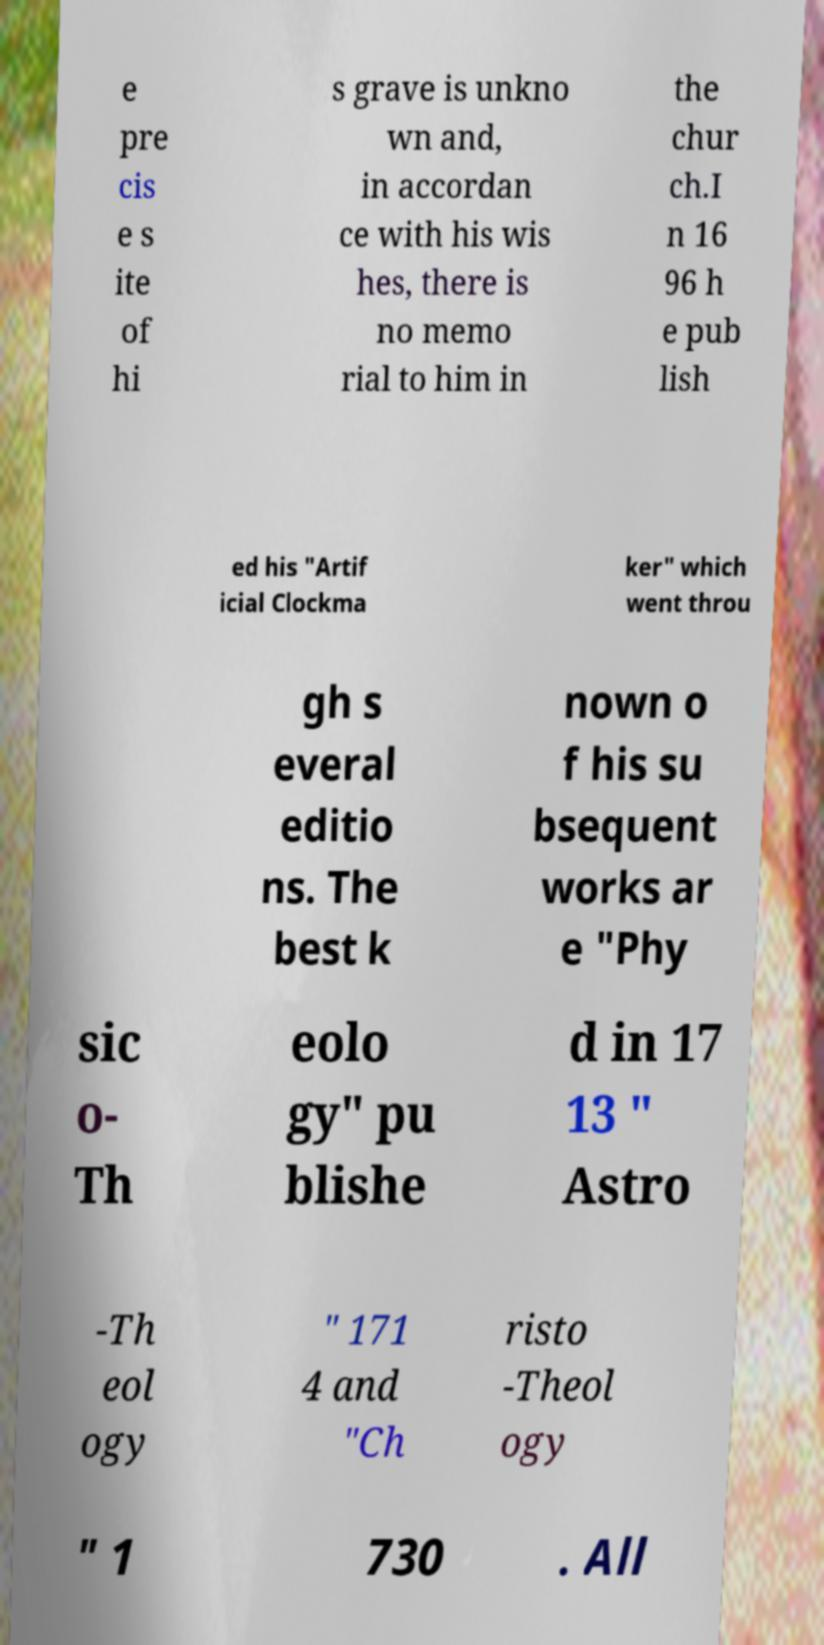There's text embedded in this image that I need extracted. Can you transcribe it verbatim? e pre cis e s ite of hi s grave is unkno wn and, in accordan ce with his wis hes, there is no memo rial to him in the chur ch.I n 16 96 h e pub lish ed his "Artif icial Clockma ker" which went throu gh s everal editio ns. The best k nown o f his su bsequent works ar e "Phy sic o- Th eolo gy" pu blishe d in 17 13 " Astro -Th eol ogy " 171 4 and "Ch risto -Theol ogy " 1 730 . All 